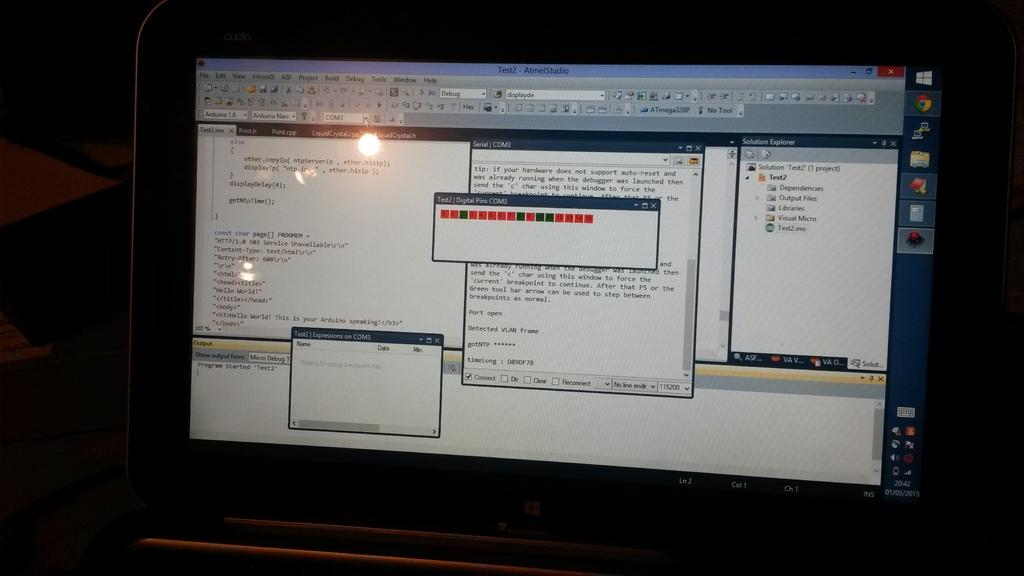Can anyone see the words here?
Your answer should be very brief. Yes. What are the words on the header at the top of the page?
Your response must be concise. Test2. 